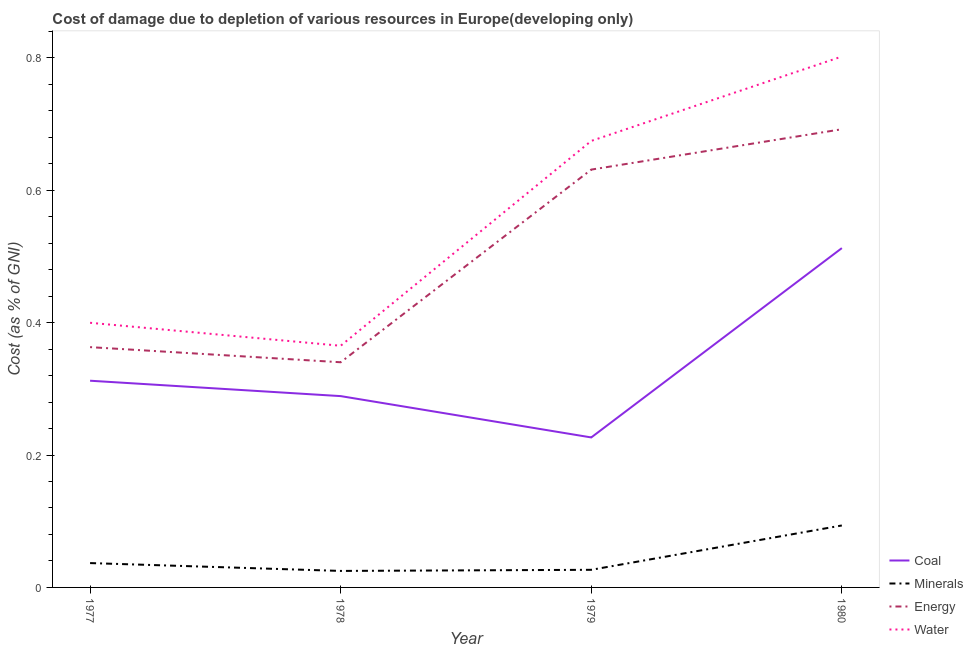How many different coloured lines are there?
Keep it short and to the point. 4. Does the line corresponding to cost of damage due to depletion of water intersect with the line corresponding to cost of damage due to depletion of energy?
Your response must be concise. No. What is the cost of damage due to depletion of minerals in 1978?
Give a very brief answer. 0.02. Across all years, what is the maximum cost of damage due to depletion of coal?
Your response must be concise. 0.51. Across all years, what is the minimum cost of damage due to depletion of minerals?
Make the answer very short. 0.02. In which year was the cost of damage due to depletion of coal maximum?
Provide a short and direct response. 1980. In which year was the cost of damage due to depletion of energy minimum?
Ensure brevity in your answer.  1978. What is the total cost of damage due to depletion of energy in the graph?
Offer a very short reply. 2.03. What is the difference between the cost of damage due to depletion of energy in 1978 and that in 1980?
Provide a succinct answer. -0.35. What is the difference between the cost of damage due to depletion of energy in 1978 and the cost of damage due to depletion of coal in 1979?
Give a very brief answer. 0.11. What is the average cost of damage due to depletion of minerals per year?
Your response must be concise. 0.05. In the year 1980, what is the difference between the cost of damage due to depletion of water and cost of damage due to depletion of coal?
Ensure brevity in your answer.  0.29. In how many years, is the cost of damage due to depletion of water greater than 0.2 %?
Provide a succinct answer. 4. What is the ratio of the cost of damage due to depletion of coal in 1977 to that in 1979?
Keep it short and to the point. 1.38. What is the difference between the highest and the second highest cost of damage due to depletion of energy?
Provide a succinct answer. 0.06. What is the difference between the highest and the lowest cost of damage due to depletion of energy?
Offer a terse response. 0.35. In how many years, is the cost of damage due to depletion of water greater than the average cost of damage due to depletion of water taken over all years?
Ensure brevity in your answer.  2. Is the sum of the cost of damage due to depletion of energy in 1978 and 1980 greater than the maximum cost of damage due to depletion of minerals across all years?
Ensure brevity in your answer.  Yes. Is it the case that in every year, the sum of the cost of damage due to depletion of coal and cost of damage due to depletion of minerals is greater than the cost of damage due to depletion of energy?
Your answer should be very brief. No. Does the cost of damage due to depletion of minerals monotonically increase over the years?
Provide a succinct answer. No. Is the cost of damage due to depletion of minerals strictly less than the cost of damage due to depletion of water over the years?
Provide a succinct answer. Yes. How many years are there in the graph?
Your answer should be compact. 4. How many legend labels are there?
Make the answer very short. 4. How are the legend labels stacked?
Provide a succinct answer. Vertical. What is the title of the graph?
Offer a terse response. Cost of damage due to depletion of various resources in Europe(developing only) . Does "Arable land" appear as one of the legend labels in the graph?
Give a very brief answer. No. What is the label or title of the Y-axis?
Offer a very short reply. Cost (as % of GNI). What is the Cost (as % of GNI) in Coal in 1977?
Provide a short and direct response. 0.31. What is the Cost (as % of GNI) of Minerals in 1977?
Provide a short and direct response. 0.04. What is the Cost (as % of GNI) of Energy in 1977?
Give a very brief answer. 0.36. What is the Cost (as % of GNI) of Water in 1977?
Your answer should be compact. 0.4. What is the Cost (as % of GNI) in Coal in 1978?
Your answer should be very brief. 0.29. What is the Cost (as % of GNI) of Minerals in 1978?
Your answer should be compact. 0.02. What is the Cost (as % of GNI) of Energy in 1978?
Your answer should be compact. 0.34. What is the Cost (as % of GNI) of Water in 1978?
Make the answer very short. 0.37. What is the Cost (as % of GNI) of Coal in 1979?
Your answer should be very brief. 0.23. What is the Cost (as % of GNI) in Minerals in 1979?
Give a very brief answer. 0.03. What is the Cost (as % of GNI) of Energy in 1979?
Keep it short and to the point. 0.63. What is the Cost (as % of GNI) in Water in 1979?
Your answer should be very brief. 0.67. What is the Cost (as % of GNI) of Coal in 1980?
Provide a short and direct response. 0.51. What is the Cost (as % of GNI) in Minerals in 1980?
Ensure brevity in your answer.  0.09. What is the Cost (as % of GNI) of Energy in 1980?
Give a very brief answer. 0.69. What is the Cost (as % of GNI) of Water in 1980?
Your answer should be compact. 0.8. Across all years, what is the maximum Cost (as % of GNI) of Coal?
Make the answer very short. 0.51. Across all years, what is the maximum Cost (as % of GNI) in Minerals?
Offer a terse response. 0.09. Across all years, what is the maximum Cost (as % of GNI) of Energy?
Your response must be concise. 0.69. Across all years, what is the maximum Cost (as % of GNI) of Water?
Your answer should be very brief. 0.8. Across all years, what is the minimum Cost (as % of GNI) of Coal?
Your answer should be very brief. 0.23. Across all years, what is the minimum Cost (as % of GNI) of Minerals?
Ensure brevity in your answer.  0.02. Across all years, what is the minimum Cost (as % of GNI) of Energy?
Your response must be concise. 0.34. Across all years, what is the minimum Cost (as % of GNI) in Water?
Offer a terse response. 0.37. What is the total Cost (as % of GNI) of Coal in the graph?
Provide a succinct answer. 1.34. What is the total Cost (as % of GNI) in Minerals in the graph?
Your response must be concise. 0.18. What is the total Cost (as % of GNI) in Energy in the graph?
Provide a short and direct response. 2.03. What is the total Cost (as % of GNI) in Water in the graph?
Offer a very short reply. 2.24. What is the difference between the Cost (as % of GNI) of Coal in 1977 and that in 1978?
Your answer should be very brief. 0.02. What is the difference between the Cost (as % of GNI) of Minerals in 1977 and that in 1978?
Provide a succinct answer. 0.01. What is the difference between the Cost (as % of GNI) in Energy in 1977 and that in 1978?
Your response must be concise. 0.02. What is the difference between the Cost (as % of GNI) in Water in 1977 and that in 1978?
Keep it short and to the point. 0.03. What is the difference between the Cost (as % of GNI) in Coal in 1977 and that in 1979?
Offer a terse response. 0.09. What is the difference between the Cost (as % of GNI) in Minerals in 1977 and that in 1979?
Your response must be concise. 0.01. What is the difference between the Cost (as % of GNI) in Energy in 1977 and that in 1979?
Keep it short and to the point. -0.27. What is the difference between the Cost (as % of GNI) of Water in 1977 and that in 1979?
Make the answer very short. -0.27. What is the difference between the Cost (as % of GNI) in Coal in 1977 and that in 1980?
Keep it short and to the point. -0.2. What is the difference between the Cost (as % of GNI) of Minerals in 1977 and that in 1980?
Give a very brief answer. -0.06. What is the difference between the Cost (as % of GNI) in Energy in 1977 and that in 1980?
Ensure brevity in your answer.  -0.33. What is the difference between the Cost (as % of GNI) in Water in 1977 and that in 1980?
Provide a succinct answer. -0.4. What is the difference between the Cost (as % of GNI) in Coal in 1978 and that in 1979?
Your answer should be very brief. 0.06. What is the difference between the Cost (as % of GNI) in Minerals in 1978 and that in 1979?
Provide a succinct answer. -0. What is the difference between the Cost (as % of GNI) of Energy in 1978 and that in 1979?
Your answer should be compact. -0.29. What is the difference between the Cost (as % of GNI) in Water in 1978 and that in 1979?
Provide a succinct answer. -0.31. What is the difference between the Cost (as % of GNI) of Coal in 1978 and that in 1980?
Provide a short and direct response. -0.22. What is the difference between the Cost (as % of GNI) of Minerals in 1978 and that in 1980?
Your answer should be compact. -0.07. What is the difference between the Cost (as % of GNI) of Energy in 1978 and that in 1980?
Make the answer very short. -0.35. What is the difference between the Cost (as % of GNI) in Water in 1978 and that in 1980?
Keep it short and to the point. -0.44. What is the difference between the Cost (as % of GNI) in Coal in 1979 and that in 1980?
Make the answer very short. -0.29. What is the difference between the Cost (as % of GNI) of Minerals in 1979 and that in 1980?
Your answer should be very brief. -0.07. What is the difference between the Cost (as % of GNI) in Energy in 1979 and that in 1980?
Provide a succinct answer. -0.06. What is the difference between the Cost (as % of GNI) in Water in 1979 and that in 1980?
Keep it short and to the point. -0.13. What is the difference between the Cost (as % of GNI) in Coal in 1977 and the Cost (as % of GNI) in Minerals in 1978?
Ensure brevity in your answer.  0.29. What is the difference between the Cost (as % of GNI) in Coal in 1977 and the Cost (as % of GNI) in Energy in 1978?
Offer a terse response. -0.03. What is the difference between the Cost (as % of GNI) of Coal in 1977 and the Cost (as % of GNI) of Water in 1978?
Give a very brief answer. -0.05. What is the difference between the Cost (as % of GNI) of Minerals in 1977 and the Cost (as % of GNI) of Energy in 1978?
Your response must be concise. -0.3. What is the difference between the Cost (as % of GNI) of Minerals in 1977 and the Cost (as % of GNI) of Water in 1978?
Provide a short and direct response. -0.33. What is the difference between the Cost (as % of GNI) of Energy in 1977 and the Cost (as % of GNI) of Water in 1978?
Ensure brevity in your answer.  -0. What is the difference between the Cost (as % of GNI) of Coal in 1977 and the Cost (as % of GNI) of Minerals in 1979?
Make the answer very short. 0.29. What is the difference between the Cost (as % of GNI) of Coal in 1977 and the Cost (as % of GNI) of Energy in 1979?
Make the answer very short. -0.32. What is the difference between the Cost (as % of GNI) in Coal in 1977 and the Cost (as % of GNI) in Water in 1979?
Your response must be concise. -0.36. What is the difference between the Cost (as % of GNI) of Minerals in 1977 and the Cost (as % of GNI) of Energy in 1979?
Offer a terse response. -0.59. What is the difference between the Cost (as % of GNI) of Minerals in 1977 and the Cost (as % of GNI) of Water in 1979?
Your answer should be very brief. -0.64. What is the difference between the Cost (as % of GNI) of Energy in 1977 and the Cost (as % of GNI) of Water in 1979?
Ensure brevity in your answer.  -0.31. What is the difference between the Cost (as % of GNI) in Coal in 1977 and the Cost (as % of GNI) in Minerals in 1980?
Offer a very short reply. 0.22. What is the difference between the Cost (as % of GNI) of Coal in 1977 and the Cost (as % of GNI) of Energy in 1980?
Your answer should be compact. -0.38. What is the difference between the Cost (as % of GNI) in Coal in 1977 and the Cost (as % of GNI) in Water in 1980?
Give a very brief answer. -0.49. What is the difference between the Cost (as % of GNI) in Minerals in 1977 and the Cost (as % of GNI) in Energy in 1980?
Your response must be concise. -0.66. What is the difference between the Cost (as % of GNI) of Minerals in 1977 and the Cost (as % of GNI) of Water in 1980?
Your response must be concise. -0.77. What is the difference between the Cost (as % of GNI) of Energy in 1977 and the Cost (as % of GNI) of Water in 1980?
Offer a very short reply. -0.44. What is the difference between the Cost (as % of GNI) of Coal in 1978 and the Cost (as % of GNI) of Minerals in 1979?
Ensure brevity in your answer.  0.26. What is the difference between the Cost (as % of GNI) of Coal in 1978 and the Cost (as % of GNI) of Energy in 1979?
Ensure brevity in your answer.  -0.34. What is the difference between the Cost (as % of GNI) in Coal in 1978 and the Cost (as % of GNI) in Water in 1979?
Provide a short and direct response. -0.39. What is the difference between the Cost (as % of GNI) in Minerals in 1978 and the Cost (as % of GNI) in Energy in 1979?
Offer a very short reply. -0.61. What is the difference between the Cost (as % of GNI) of Minerals in 1978 and the Cost (as % of GNI) of Water in 1979?
Provide a succinct answer. -0.65. What is the difference between the Cost (as % of GNI) in Energy in 1978 and the Cost (as % of GNI) in Water in 1979?
Offer a terse response. -0.33. What is the difference between the Cost (as % of GNI) in Coal in 1978 and the Cost (as % of GNI) in Minerals in 1980?
Your answer should be very brief. 0.2. What is the difference between the Cost (as % of GNI) of Coal in 1978 and the Cost (as % of GNI) of Energy in 1980?
Your answer should be very brief. -0.4. What is the difference between the Cost (as % of GNI) of Coal in 1978 and the Cost (as % of GNI) of Water in 1980?
Offer a terse response. -0.51. What is the difference between the Cost (as % of GNI) of Minerals in 1978 and the Cost (as % of GNI) of Energy in 1980?
Your response must be concise. -0.67. What is the difference between the Cost (as % of GNI) of Minerals in 1978 and the Cost (as % of GNI) of Water in 1980?
Ensure brevity in your answer.  -0.78. What is the difference between the Cost (as % of GNI) of Energy in 1978 and the Cost (as % of GNI) of Water in 1980?
Provide a short and direct response. -0.46. What is the difference between the Cost (as % of GNI) in Coal in 1979 and the Cost (as % of GNI) in Minerals in 1980?
Keep it short and to the point. 0.13. What is the difference between the Cost (as % of GNI) in Coal in 1979 and the Cost (as % of GNI) in Energy in 1980?
Your answer should be very brief. -0.47. What is the difference between the Cost (as % of GNI) in Coal in 1979 and the Cost (as % of GNI) in Water in 1980?
Your response must be concise. -0.58. What is the difference between the Cost (as % of GNI) of Minerals in 1979 and the Cost (as % of GNI) of Energy in 1980?
Ensure brevity in your answer.  -0.67. What is the difference between the Cost (as % of GNI) of Minerals in 1979 and the Cost (as % of GNI) of Water in 1980?
Provide a short and direct response. -0.78. What is the difference between the Cost (as % of GNI) of Energy in 1979 and the Cost (as % of GNI) of Water in 1980?
Offer a terse response. -0.17. What is the average Cost (as % of GNI) of Coal per year?
Your answer should be compact. 0.34. What is the average Cost (as % of GNI) of Minerals per year?
Your answer should be very brief. 0.05. What is the average Cost (as % of GNI) of Energy per year?
Give a very brief answer. 0.51. What is the average Cost (as % of GNI) in Water per year?
Offer a very short reply. 0.56. In the year 1977, what is the difference between the Cost (as % of GNI) of Coal and Cost (as % of GNI) of Minerals?
Your answer should be very brief. 0.28. In the year 1977, what is the difference between the Cost (as % of GNI) of Coal and Cost (as % of GNI) of Energy?
Keep it short and to the point. -0.05. In the year 1977, what is the difference between the Cost (as % of GNI) in Coal and Cost (as % of GNI) in Water?
Your answer should be compact. -0.09. In the year 1977, what is the difference between the Cost (as % of GNI) of Minerals and Cost (as % of GNI) of Energy?
Your answer should be compact. -0.33. In the year 1977, what is the difference between the Cost (as % of GNI) in Minerals and Cost (as % of GNI) in Water?
Make the answer very short. -0.36. In the year 1977, what is the difference between the Cost (as % of GNI) in Energy and Cost (as % of GNI) in Water?
Your answer should be very brief. -0.04. In the year 1978, what is the difference between the Cost (as % of GNI) in Coal and Cost (as % of GNI) in Minerals?
Keep it short and to the point. 0.26. In the year 1978, what is the difference between the Cost (as % of GNI) in Coal and Cost (as % of GNI) in Energy?
Ensure brevity in your answer.  -0.05. In the year 1978, what is the difference between the Cost (as % of GNI) in Coal and Cost (as % of GNI) in Water?
Your answer should be compact. -0.08. In the year 1978, what is the difference between the Cost (as % of GNI) in Minerals and Cost (as % of GNI) in Energy?
Ensure brevity in your answer.  -0.32. In the year 1978, what is the difference between the Cost (as % of GNI) of Minerals and Cost (as % of GNI) of Water?
Give a very brief answer. -0.34. In the year 1978, what is the difference between the Cost (as % of GNI) in Energy and Cost (as % of GNI) in Water?
Your answer should be very brief. -0.02. In the year 1979, what is the difference between the Cost (as % of GNI) of Coal and Cost (as % of GNI) of Minerals?
Provide a short and direct response. 0.2. In the year 1979, what is the difference between the Cost (as % of GNI) of Coal and Cost (as % of GNI) of Energy?
Keep it short and to the point. -0.4. In the year 1979, what is the difference between the Cost (as % of GNI) of Coal and Cost (as % of GNI) of Water?
Give a very brief answer. -0.45. In the year 1979, what is the difference between the Cost (as % of GNI) of Minerals and Cost (as % of GNI) of Energy?
Ensure brevity in your answer.  -0.6. In the year 1979, what is the difference between the Cost (as % of GNI) of Minerals and Cost (as % of GNI) of Water?
Your answer should be compact. -0.65. In the year 1979, what is the difference between the Cost (as % of GNI) of Energy and Cost (as % of GNI) of Water?
Your answer should be compact. -0.04. In the year 1980, what is the difference between the Cost (as % of GNI) in Coal and Cost (as % of GNI) in Minerals?
Offer a terse response. 0.42. In the year 1980, what is the difference between the Cost (as % of GNI) in Coal and Cost (as % of GNI) in Energy?
Offer a terse response. -0.18. In the year 1980, what is the difference between the Cost (as % of GNI) in Coal and Cost (as % of GNI) in Water?
Provide a succinct answer. -0.29. In the year 1980, what is the difference between the Cost (as % of GNI) in Minerals and Cost (as % of GNI) in Energy?
Your response must be concise. -0.6. In the year 1980, what is the difference between the Cost (as % of GNI) in Minerals and Cost (as % of GNI) in Water?
Your answer should be compact. -0.71. In the year 1980, what is the difference between the Cost (as % of GNI) in Energy and Cost (as % of GNI) in Water?
Provide a short and direct response. -0.11. What is the ratio of the Cost (as % of GNI) of Coal in 1977 to that in 1978?
Your response must be concise. 1.08. What is the ratio of the Cost (as % of GNI) in Minerals in 1977 to that in 1978?
Offer a terse response. 1.48. What is the ratio of the Cost (as % of GNI) in Energy in 1977 to that in 1978?
Make the answer very short. 1.07. What is the ratio of the Cost (as % of GNI) of Water in 1977 to that in 1978?
Keep it short and to the point. 1.1. What is the ratio of the Cost (as % of GNI) of Coal in 1977 to that in 1979?
Your answer should be compact. 1.38. What is the ratio of the Cost (as % of GNI) of Minerals in 1977 to that in 1979?
Your answer should be compact. 1.38. What is the ratio of the Cost (as % of GNI) in Energy in 1977 to that in 1979?
Your answer should be very brief. 0.58. What is the ratio of the Cost (as % of GNI) in Water in 1977 to that in 1979?
Offer a terse response. 0.59. What is the ratio of the Cost (as % of GNI) of Coal in 1977 to that in 1980?
Offer a very short reply. 0.61. What is the ratio of the Cost (as % of GNI) of Minerals in 1977 to that in 1980?
Your answer should be compact. 0.39. What is the ratio of the Cost (as % of GNI) of Energy in 1977 to that in 1980?
Ensure brevity in your answer.  0.52. What is the ratio of the Cost (as % of GNI) of Water in 1977 to that in 1980?
Offer a very short reply. 0.5. What is the ratio of the Cost (as % of GNI) of Coal in 1978 to that in 1979?
Your answer should be very brief. 1.28. What is the ratio of the Cost (as % of GNI) in Minerals in 1978 to that in 1979?
Ensure brevity in your answer.  0.94. What is the ratio of the Cost (as % of GNI) of Energy in 1978 to that in 1979?
Give a very brief answer. 0.54. What is the ratio of the Cost (as % of GNI) in Water in 1978 to that in 1979?
Provide a succinct answer. 0.54. What is the ratio of the Cost (as % of GNI) in Coal in 1978 to that in 1980?
Offer a very short reply. 0.56. What is the ratio of the Cost (as % of GNI) of Minerals in 1978 to that in 1980?
Give a very brief answer. 0.27. What is the ratio of the Cost (as % of GNI) in Energy in 1978 to that in 1980?
Offer a very short reply. 0.49. What is the ratio of the Cost (as % of GNI) in Water in 1978 to that in 1980?
Offer a very short reply. 0.46. What is the ratio of the Cost (as % of GNI) in Coal in 1979 to that in 1980?
Keep it short and to the point. 0.44. What is the ratio of the Cost (as % of GNI) in Minerals in 1979 to that in 1980?
Make the answer very short. 0.28. What is the ratio of the Cost (as % of GNI) of Energy in 1979 to that in 1980?
Provide a short and direct response. 0.91. What is the ratio of the Cost (as % of GNI) in Water in 1979 to that in 1980?
Provide a short and direct response. 0.84. What is the difference between the highest and the second highest Cost (as % of GNI) of Coal?
Offer a very short reply. 0.2. What is the difference between the highest and the second highest Cost (as % of GNI) of Minerals?
Your answer should be compact. 0.06. What is the difference between the highest and the second highest Cost (as % of GNI) in Energy?
Make the answer very short. 0.06. What is the difference between the highest and the second highest Cost (as % of GNI) in Water?
Keep it short and to the point. 0.13. What is the difference between the highest and the lowest Cost (as % of GNI) of Coal?
Provide a short and direct response. 0.29. What is the difference between the highest and the lowest Cost (as % of GNI) of Minerals?
Your answer should be very brief. 0.07. What is the difference between the highest and the lowest Cost (as % of GNI) of Energy?
Offer a very short reply. 0.35. What is the difference between the highest and the lowest Cost (as % of GNI) in Water?
Provide a succinct answer. 0.44. 